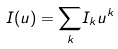Convert formula to latex. <formula><loc_0><loc_0><loc_500><loc_500>I ( u ) = \underset { k } { \sum } I _ { k } u ^ { k }</formula> 